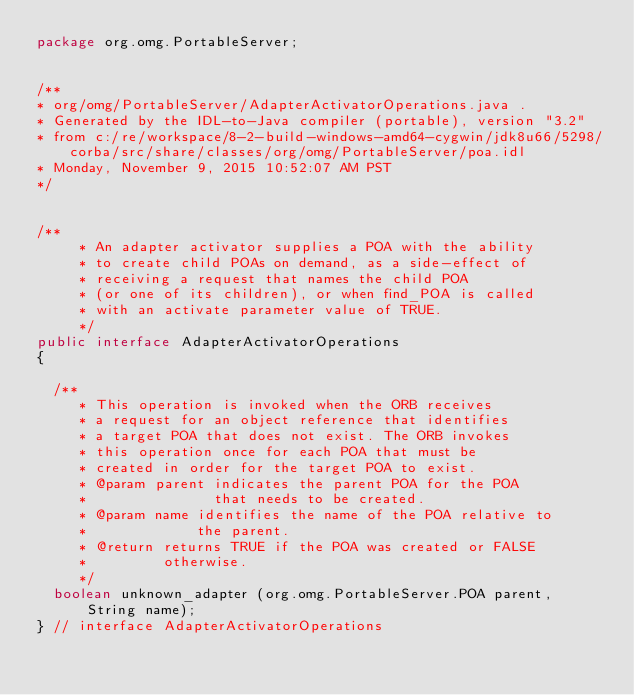<code> <loc_0><loc_0><loc_500><loc_500><_Java_>package org.omg.PortableServer;


/**
* org/omg/PortableServer/AdapterActivatorOperations.java .
* Generated by the IDL-to-Java compiler (portable), version "3.2"
* from c:/re/workspace/8-2-build-windows-amd64-cygwin/jdk8u66/5298/corba/src/share/classes/org/omg/PortableServer/poa.idl
* Monday, November 9, 2015 10:52:07 AM PST
*/


/**
	 * An adapter activator supplies a POA with the ability 
	 * to create child POAs on demand, as a side-effect of 
	 * receiving a request that names the child POA 
	 * (or one of its children), or when find_POA is called 
	 * with an activate parameter value of TRUE.
	 */
public interface AdapterActivatorOperations 
{

  /**
	 * This operation is invoked when the ORB receives 
	 * a request for an object reference that identifies 
	 * a target POA that does not exist. The ORB invokes 
	 * this operation once for each POA that must be 
	 * created in order for the target POA to exist.
	 * @param parent indicates the parent POA for the POA
	 *               that needs to be created.
	 * @param name identifies the name of the POA relative to
	 *             the parent.
	 * @return returns TRUE if the POA was created or FALSE
	 *         otherwise.
	 */
  boolean unknown_adapter (org.omg.PortableServer.POA parent, String name);
} // interface AdapterActivatorOperations
</code> 